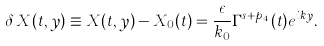<formula> <loc_0><loc_0><loc_500><loc_500>\delta \, X ( t , y ) \equiv X ( t , y ) - X _ { 0 } ( t ) = \frac { \epsilon } { k _ { 0 } } \Gamma ^ { s + p _ { 4 } } ( t ) e ^ { i k y } .</formula> 